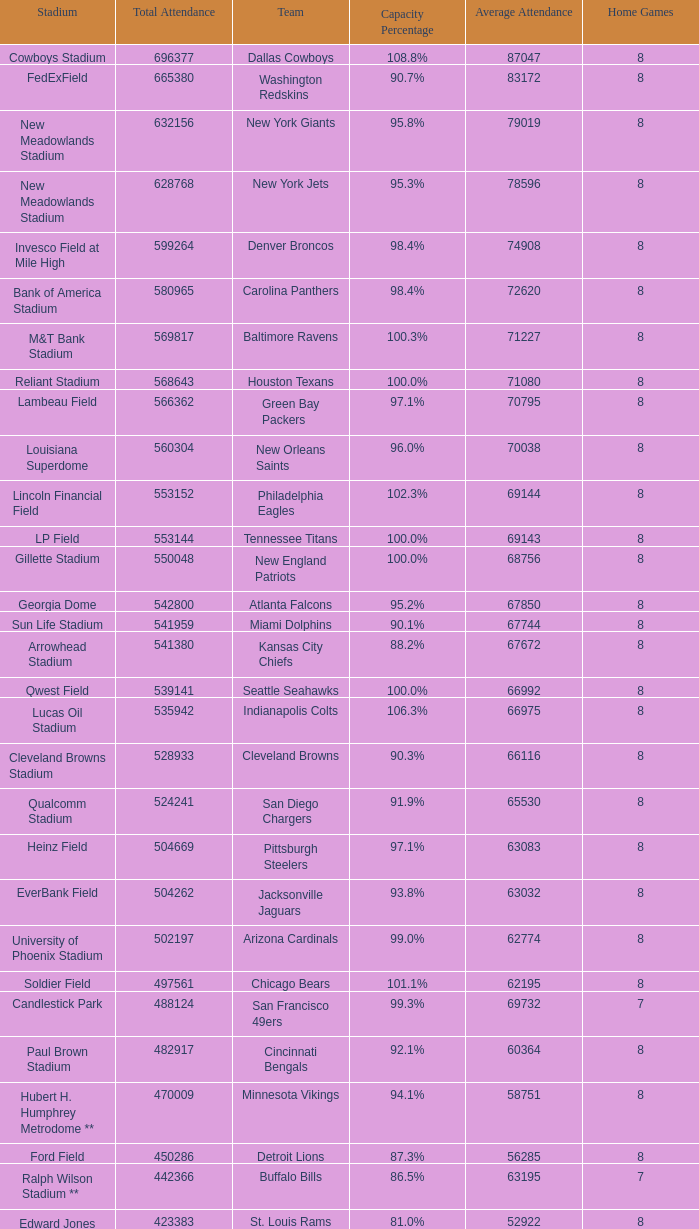How many teams had a 99.3% capacity rating? 1.0. 